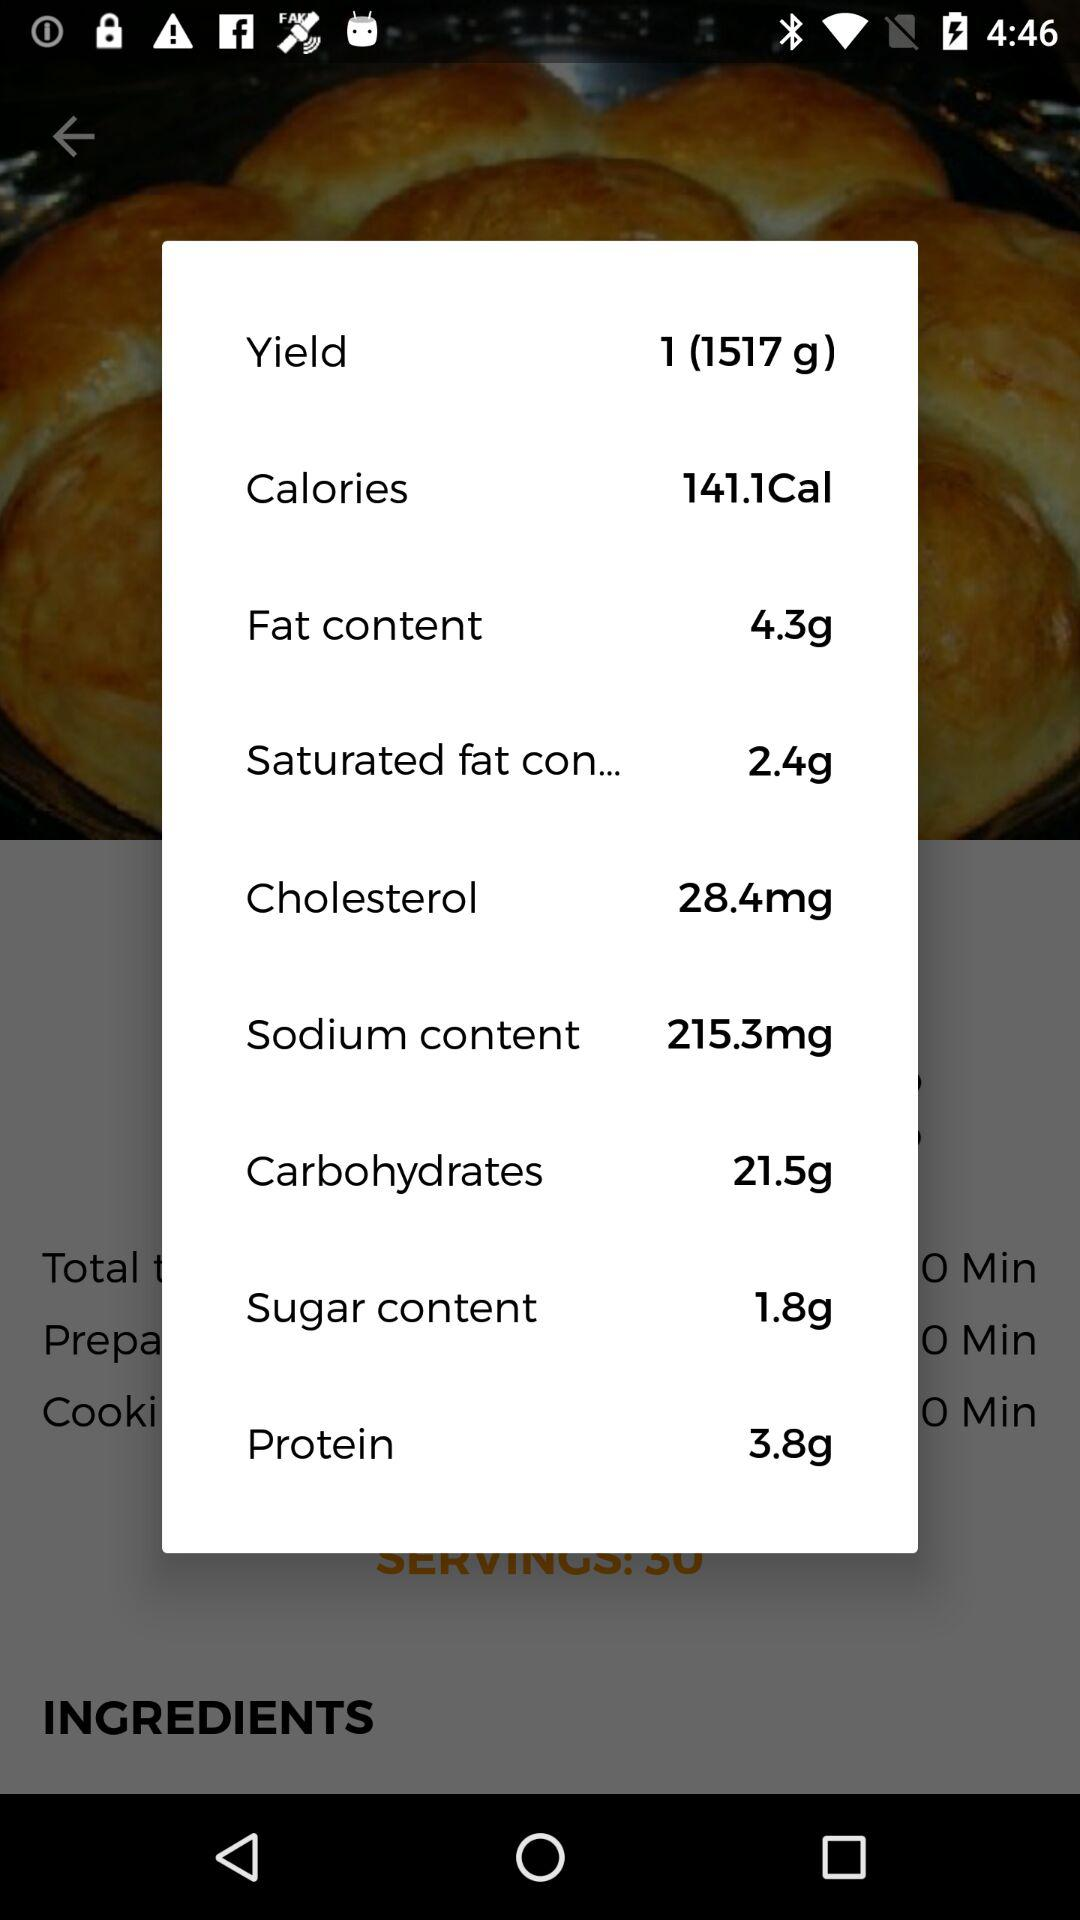How many calories are in the recipe?
Answer the question using a single word or phrase. 141.1Cal 